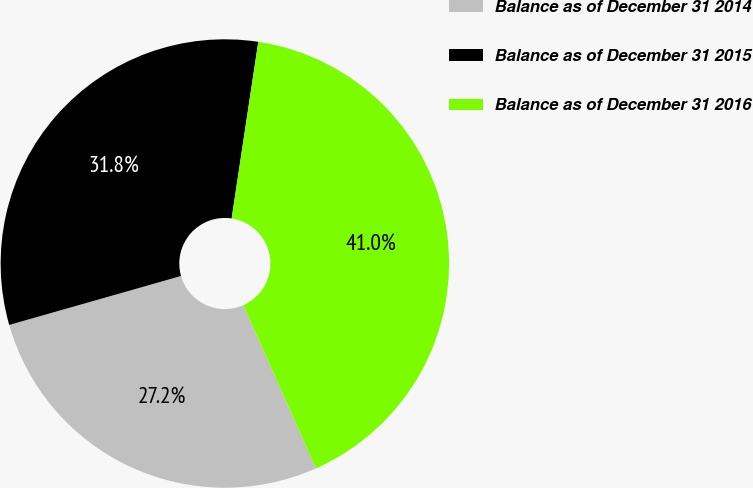<chart> <loc_0><loc_0><loc_500><loc_500><pie_chart><fcel>Balance as of December 31 2014<fcel>Balance as of December 31 2015<fcel>Balance as of December 31 2016<nl><fcel>27.24%<fcel>31.8%<fcel>40.96%<nl></chart> 